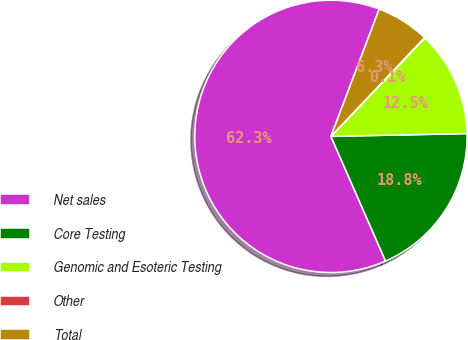Convert chart. <chart><loc_0><loc_0><loc_500><loc_500><pie_chart><fcel>Net sales<fcel>Core Testing<fcel>Genomic and Esoteric Testing<fcel>Other<fcel>Total<nl><fcel>62.34%<fcel>18.75%<fcel>12.53%<fcel>0.07%<fcel>6.3%<nl></chart> 